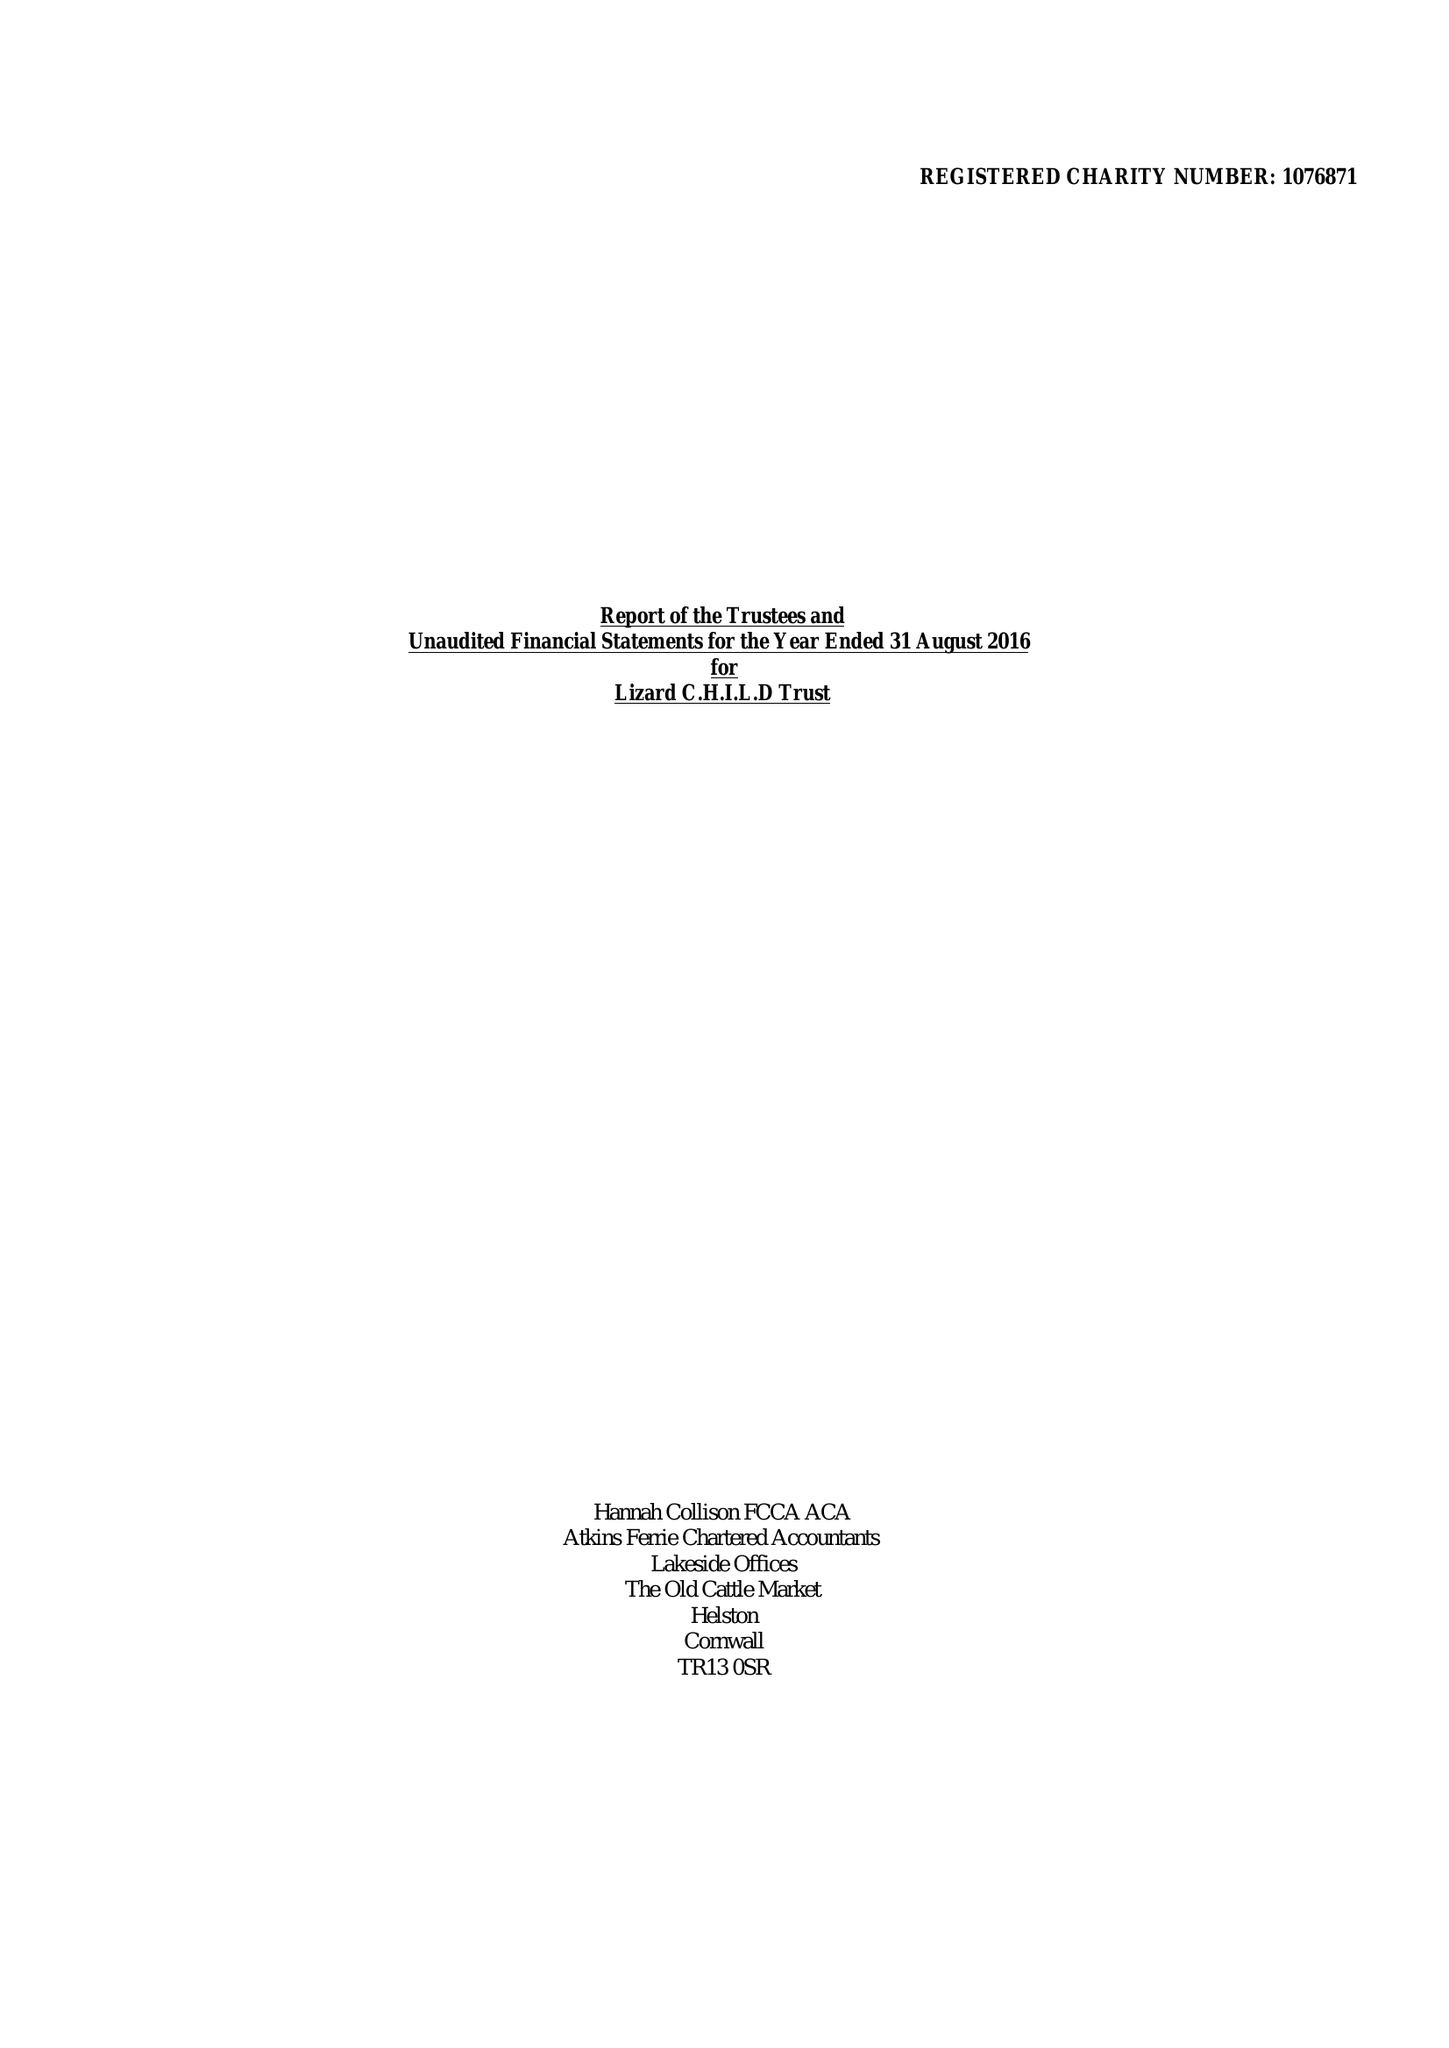What is the value for the report_date?
Answer the question using a single word or phrase. 2016-08-31 